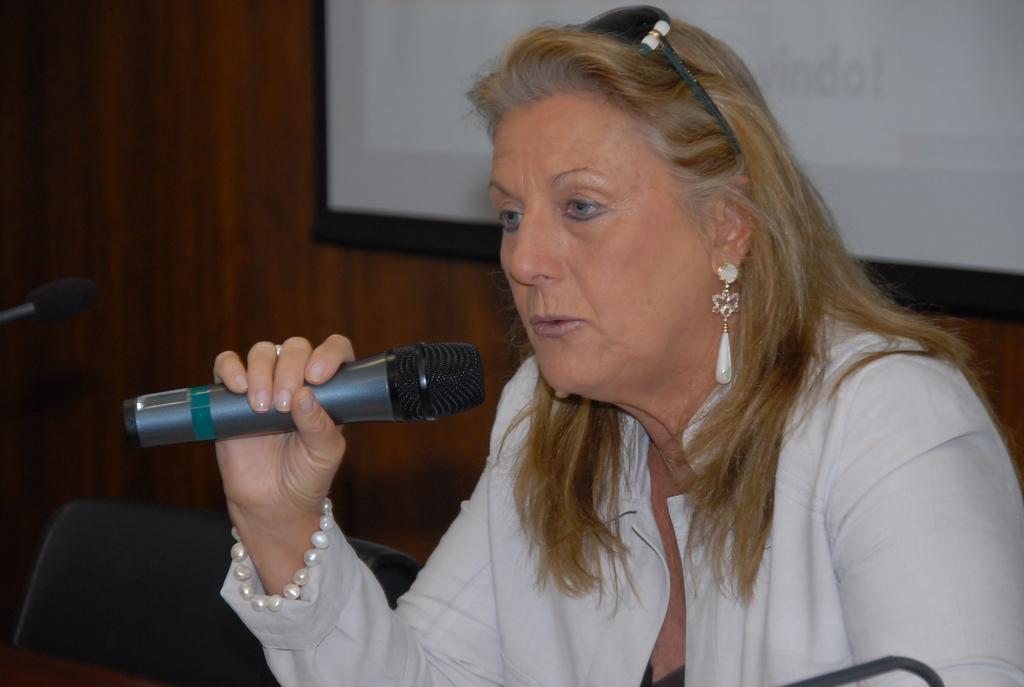In one or two sentences, can you explain what this image depicts? There is a women with white dress and with pearl bracelet, she is holding a microphone and she is talking, there is a screen at the back and chair beside of the women 